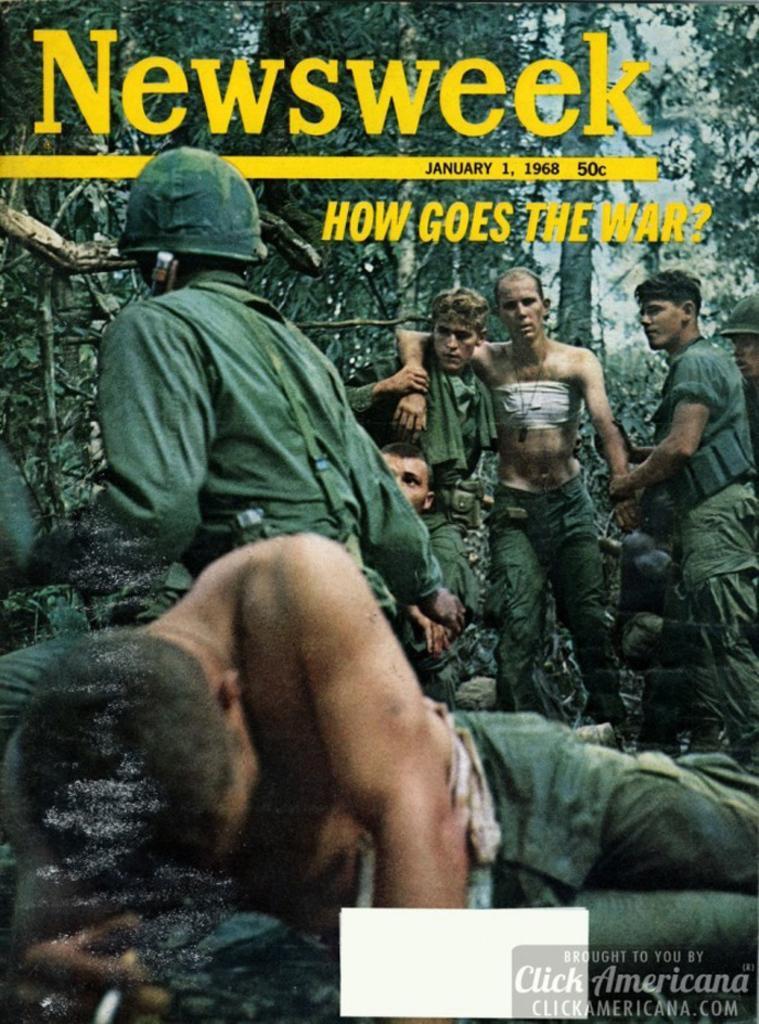Could you give a brief overview of what you see in this image? In this picture we can see an object seems to be the poster which include the pictures and in the foreground we can see a person lying and on the left we can see another person wearing helmet and seems to be sitting. In the background we can see the group of persons, sky, trees and we can see the watermarks on the image. 